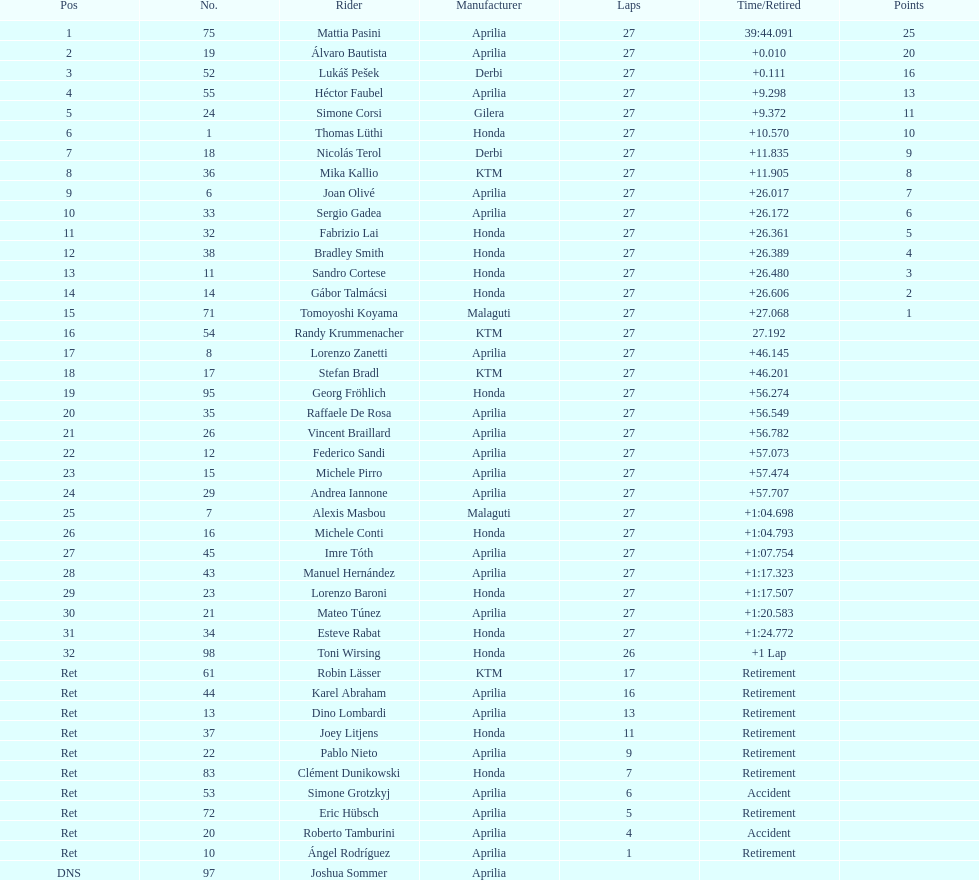Which rider came in first with 25 points? Mattia Pasini. 